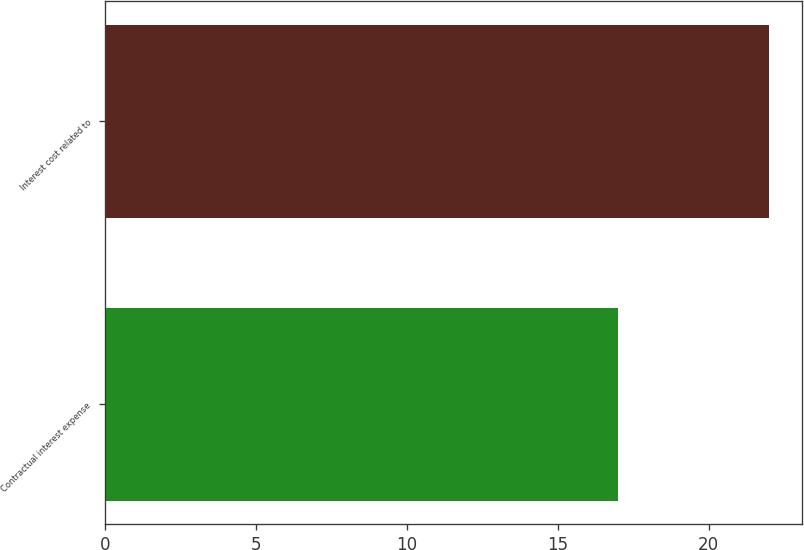<chart> <loc_0><loc_0><loc_500><loc_500><bar_chart><fcel>Contractual interest expense<fcel>Interest cost related to<nl><fcel>17<fcel>22<nl></chart> 